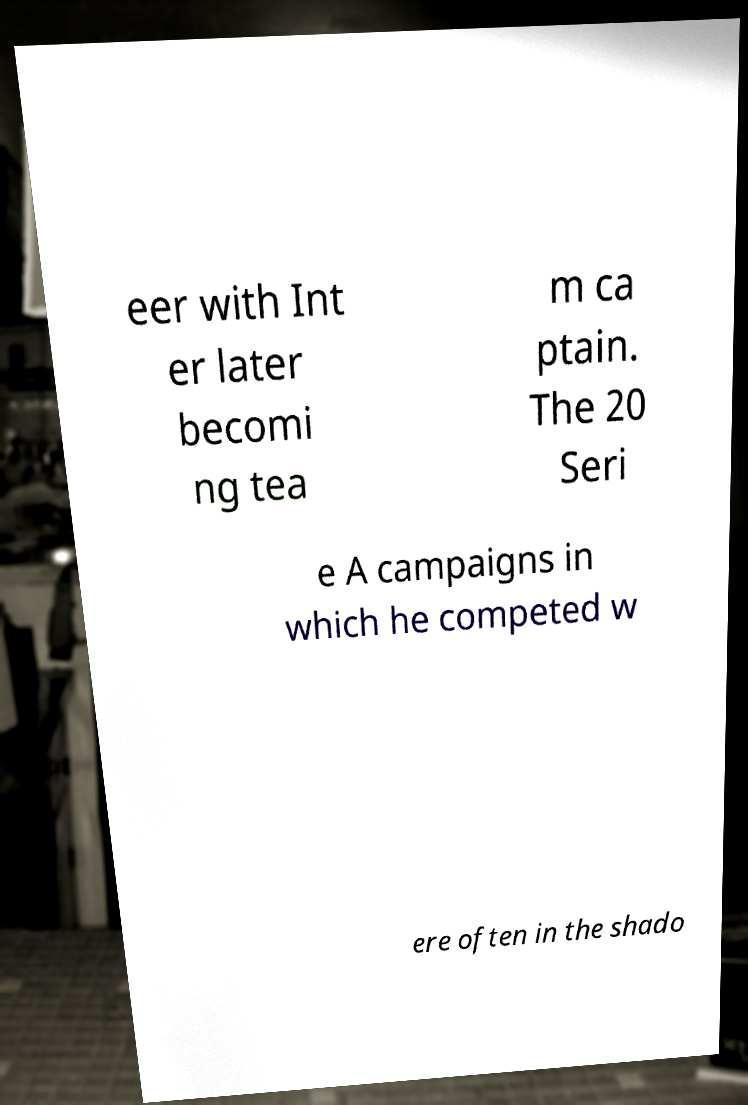Could you assist in decoding the text presented in this image and type it out clearly? eer with Int er later becomi ng tea m ca ptain. The 20 Seri e A campaigns in which he competed w ere often in the shado 